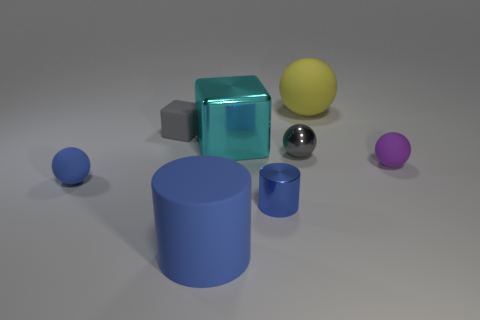Add 2 purple matte things. How many objects exist? 10 Subtract all cubes. How many objects are left? 6 Subtract 0 cyan cylinders. How many objects are left? 8 Subtract all purple spheres. Subtract all small blue objects. How many objects are left? 5 Add 8 metal cubes. How many metal cubes are left? 9 Add 8 small yellow cubes. How many small yellow cubes exist? 8 